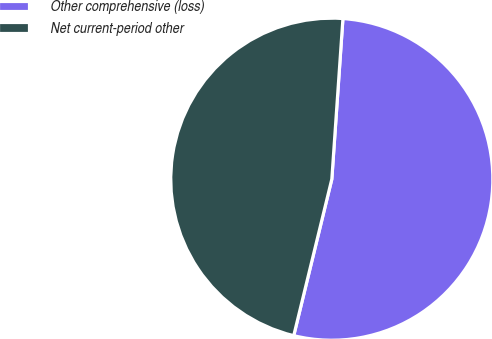Convert chart. <chart><loc_0><loc_0><loc_500><loc_500><pie_chart><fcel>Other comprehensive (loss)<fcel>Net current-period other<nl><fcel>52.7%<fcel>47.3%<nl></chart> 